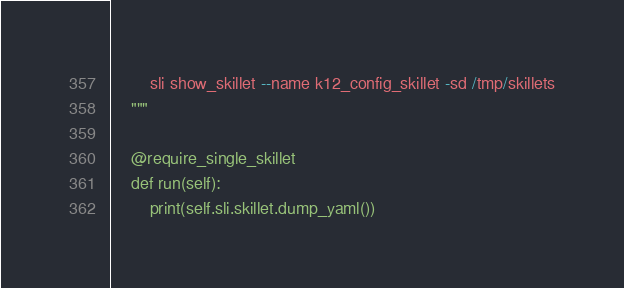Convert code to text. <code><loc_0><loc_0><loc_500><loc_500><_Python_>        sli show_skillet --name k12_config_skillet -sd /tmp/skillets
    """

    @require_single_skillet
    def run(self):
        print(self.sli.skillet.dump_yaml())
</code> 